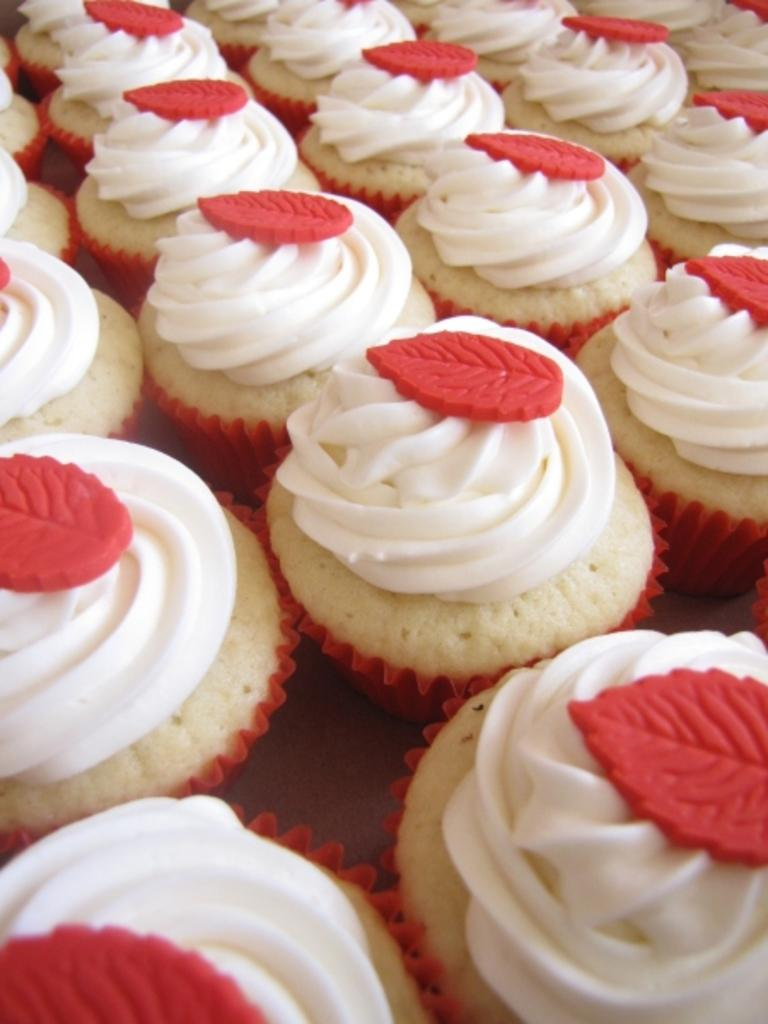What type of dessert can be seen in the image? There are cupcakes in the image. What is on top of the cupcakes? The cupcakes have whipped cream on them. How many eggs are used in the process of making the cupcakes in the image? There is no information about the process of making the cupcakes or the number of eggs used in the image. 